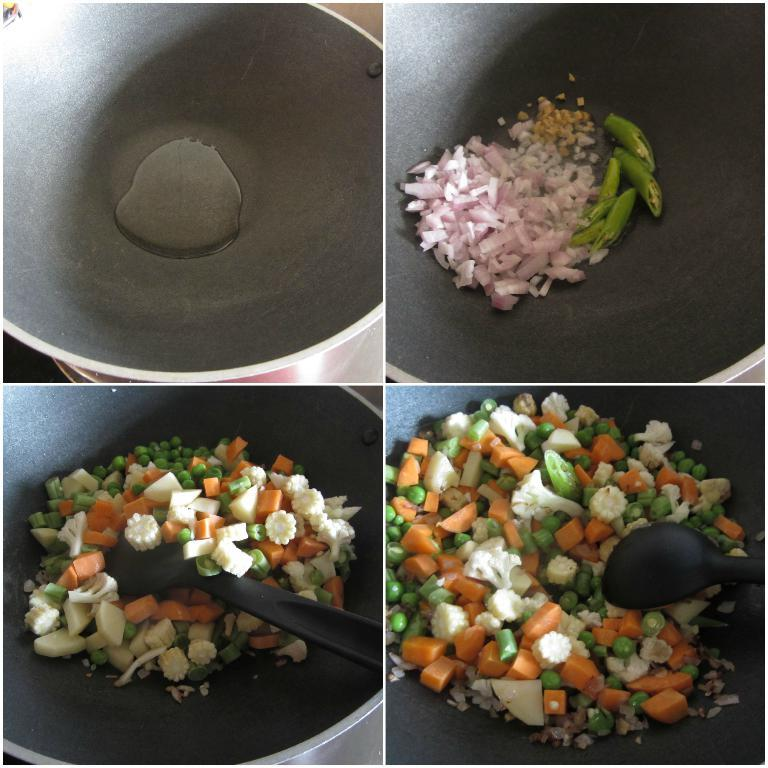What type of artwork is depicted in the image? The image is a collage. What is the main subject of the collage? The collage contains food items. How are the food items presented in the collage? The food items are in containers. What month is depicted in the collage? There is no month depicted in the collage, as it features food items in containers. Can you identify any insects in the collage? There are no insects present in the collage; it contains only food items in containers. 